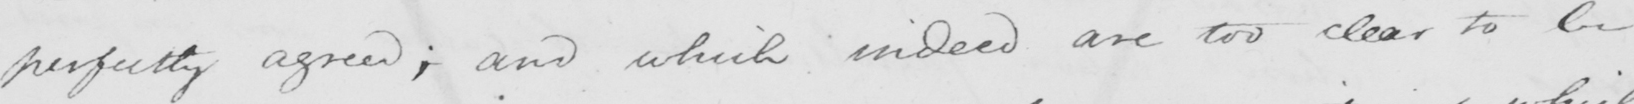Can you tell me what this handwritten text says? perfectly agreed ; and which indeed are too clear to be 